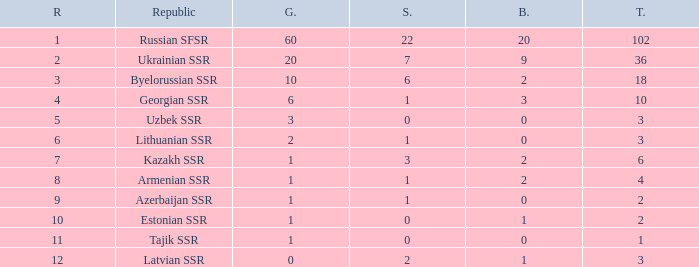What is the sum of silvers for teams with ranks over 3 and totals under 2? 0.0. Could you help me parse every detail presented in this table? {'header': ['R', 'Republic', 'G.', 'S.', 'B.', 'T.'], 'rows': [['1', 'Russian SFSR', '60', '22', '20', '102'], ['2', 'Ukrainian SSR', '20', '7', '9', '36'], ['3', 'Byelorussian SSR', '10', '6', '2', '18'], ['4', 'Georgian SSR', '6', '1', '3', '10'], ['5', 'Uzbek SSR', '3', '0', '0', '3'], ['6', 'Lithuanian SSR', '2', '1', '0', '3'], ['7', 'Kazakh SSR', '1', '3', '2', '6'], ['8', 'Armenian SSR', '1', '1', '2', '4'], ['9', 'Azerbaijan SSR', '1', '1', '0', '2'], ['10', 'Estonian SSR', '1', '0', '1', '2'], ['11', 'Tajik SSR', '1', '0', '0', '1'], ['12', 'Latvian SSR', '0', '2', '1', '3']]} 